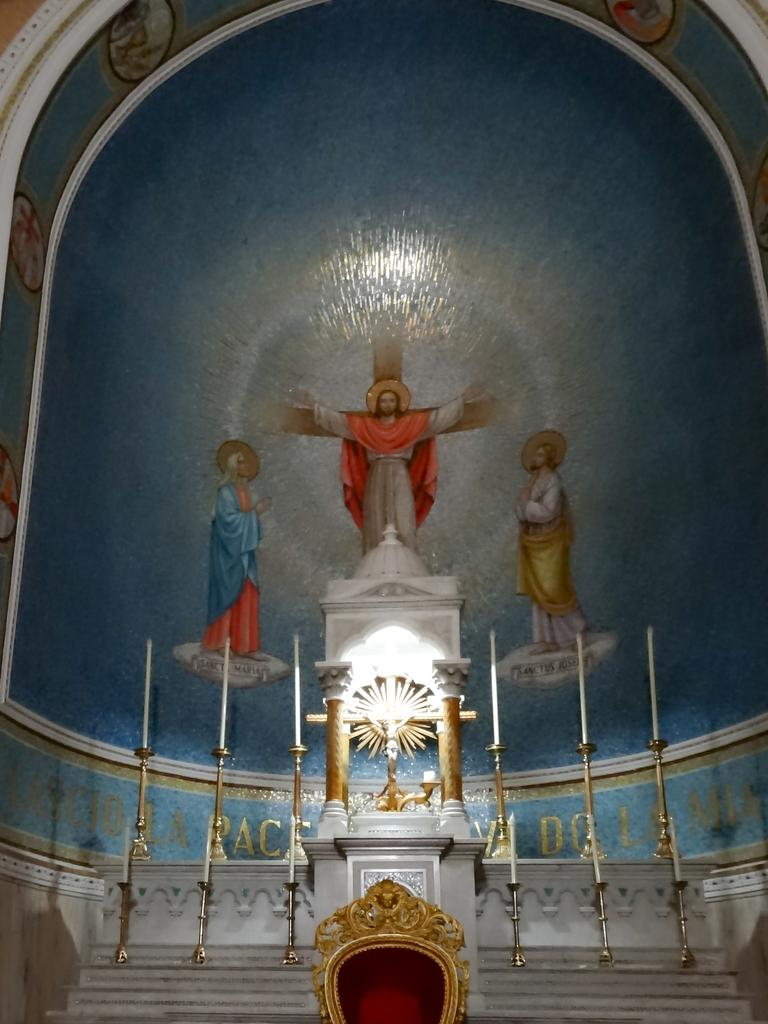What objects are on stands in the image? There are candles on stands in the image. What architectural feature can be seen in the image? There are steps and pillars in the image. What type of artwork is present in the image? There is a statue in the image. What is the object in the image? There is an object in the image, but its specific nature is not mentioned in the facts. What can be seen on the wall in the background of the image? There is a painting on the wall in the background of the image. How many bushes are present in the image? There is no mention of bushes in the provided facts, so it cannot be determined from the image. What type of cork can be seen in the image? There is no mention of cork in the provided facts, so it cannot be determined from the image. 